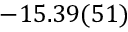Convert formula to latex. <formula><loc_0><loc_0><loc_500><loc_500>- 1 5 . 3 9 ( 5 1 )</formula> 